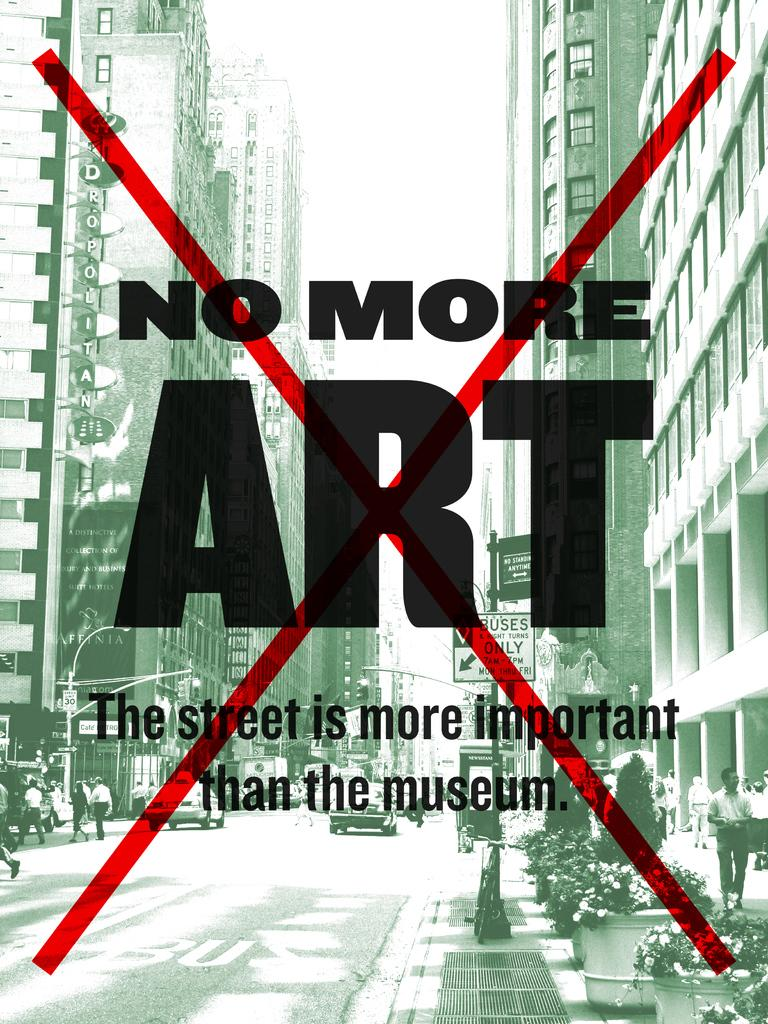Provide a one-sentence caption for the provided image. A poster with the words No More ART crossed out with a red X. 